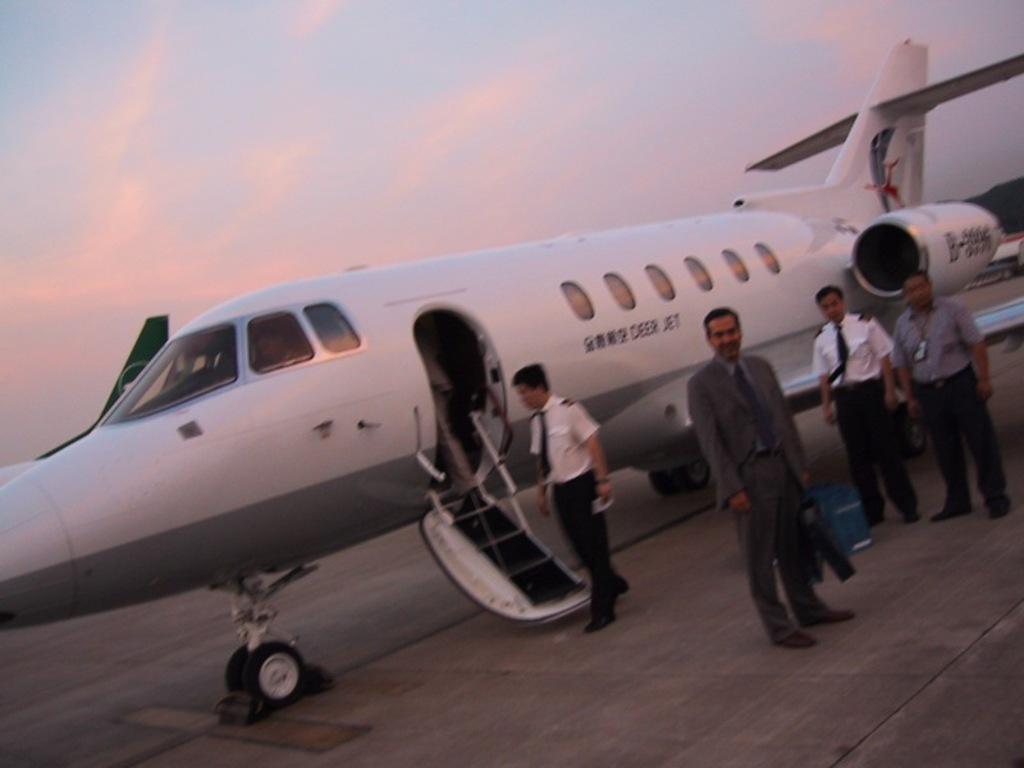Can you describe this image briefly? In this picture I can see there is a airplane and it has windows, wings and there are few people standing here holding the suitcase and the sky is clear. 